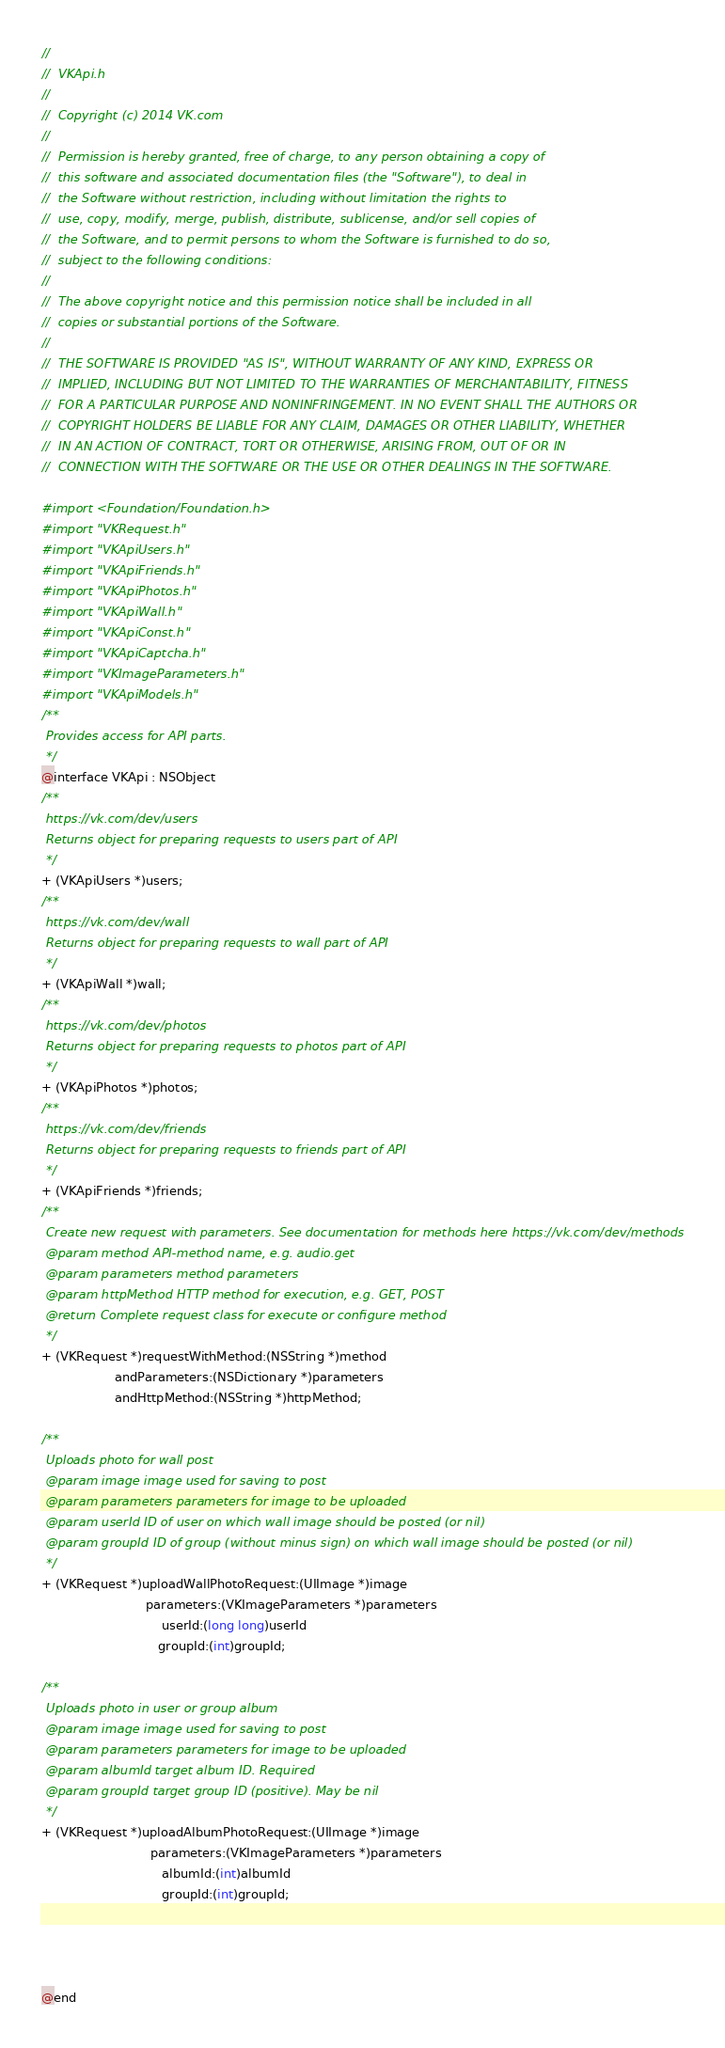Convert code to text. <code><loc_0><loc_0><loc_500><loc_500><_C_>//
//  VKApi.h
//
//  Copyright (c) 2014 VK.com
//
//  Permission is hereby granted, free of charge, to any person obtaining a copy of
//  this software and associated documentation files (the "Software"), to deal in
//  the Software without restriction, including without limitation the rights to
//  use, copy, modify, merge, publish, distribute, sublicense, and/or sell copies of
//  the Software, and to permit persons to whom the Software is furnished to do so,
//  subject to the following conditions:
//
//  The above copyright notice and this permission notice shall be included in all
//  copies or substantial portions of the Software.
//
//  THE SOFTWARE IS PROVIDED "AS IS", WITHOUT WARRANTY OF ANY KIND, EXPRESS OR
//  IMPLIED, INCLUDING BUT NOT LIMITED TO THE WARRANTIES OF MERCHANTABILITY, FITNESS
//  FOR A PARTICULAR PURPOSE AND NONINFRINGEMENT. IN NO EVENT SHALL THE AUTHORS OR
//  COPYRIGHT HOLDERS BE LIABLE FOR ANY CLAIM, DAMAGES OR OTHER LIABILITY, WHETHER
//  IN AN ACTION OF CONTRACT, TORT OR OTHERWISE, ARISING FROM, OUT OF OR IN
//  CONNECTION WITH THE SOFTWARE OR THE USE OR OTHER DEALINGS IN THE SOFTWARE.

#import <Foundation/Foundation.h>
#import "VKRequest.h"
#import "VKApiUsers.h"
#import "VKApiFriends.h"
#import "VKApiPhotos.h"
#import "VKApiWall.h"
#import "VKApiConst.h"
#import "VKApiCaptcha.h"
#import "VKImageParameters.h"
#import "VKApiModels.h"
/**
 Provides access for API parts.
 */
@interface VKApi : NSObject
/**
 https://vk.com/dev/users
 Returns object for preparing requests to users part of API
 */
+ (VKApiUsers *)users;
/**
 https://vk.com/dev/wall
 Returns object for preparing requests to wall part of API
 */
+ (VKApiWall *)wall;
/**
 https://vk.com/dev/photos
 Returns object for preparing requests to photos part of API
 */
+ (VKApiPhotos *)photos;
/**
 https://vk.com/dev/friends
 Returns object for preparing requests to friends part of API
 */
+ (VKApiFriends *)friends;
/**
 Create new request with parameters. See documentation for methods here https://vk.com/dev/methods
 @param method API-method name, e.g. audio.get
 @param parameters method parameters
 @param httpMethod HTTP method for execution, e.g. GET, POST
 @return Complete request class for execute or configure method
 */
+ (VKRequest *)requestWithMethod:(NSString *)method
                   andParameters:(NSDictionary *)parameters
                   andHttpMethod:(NSString *)httpMethod;

/**
 Uploads photo for wall post
 @param image image used for saving to post
 @param parameters parameters for image to be uploaded
 @param userId ID of user on which wall image should be posted (or nil)
 @param groupId ID of group (without minus sign) on which wall image should be posted (or nil)
 */
+ (VKRequest *)uploadWallPhotoRequest:(UIImage *)image
                           parameters:(VKImageParameters *)parameters
                               userId:(long long)userId
                              groupId:(int)groupId;

/**
 Uploads photo in user or group album
 @param image image used for saving to post
 @param parameters parameters for image to be uploaded
 @param albumId target album ID. Required
 @param groupId target group ID (positive). May be nil
 */
+ (VKRequest *)uploadAlbumPhotoRequest:(UIImage *)image
                            parameters:(VKImageParameters *)parameters
                               albumId:(int)albumId
                               groupId:(int)groupId;




@end
</code> 